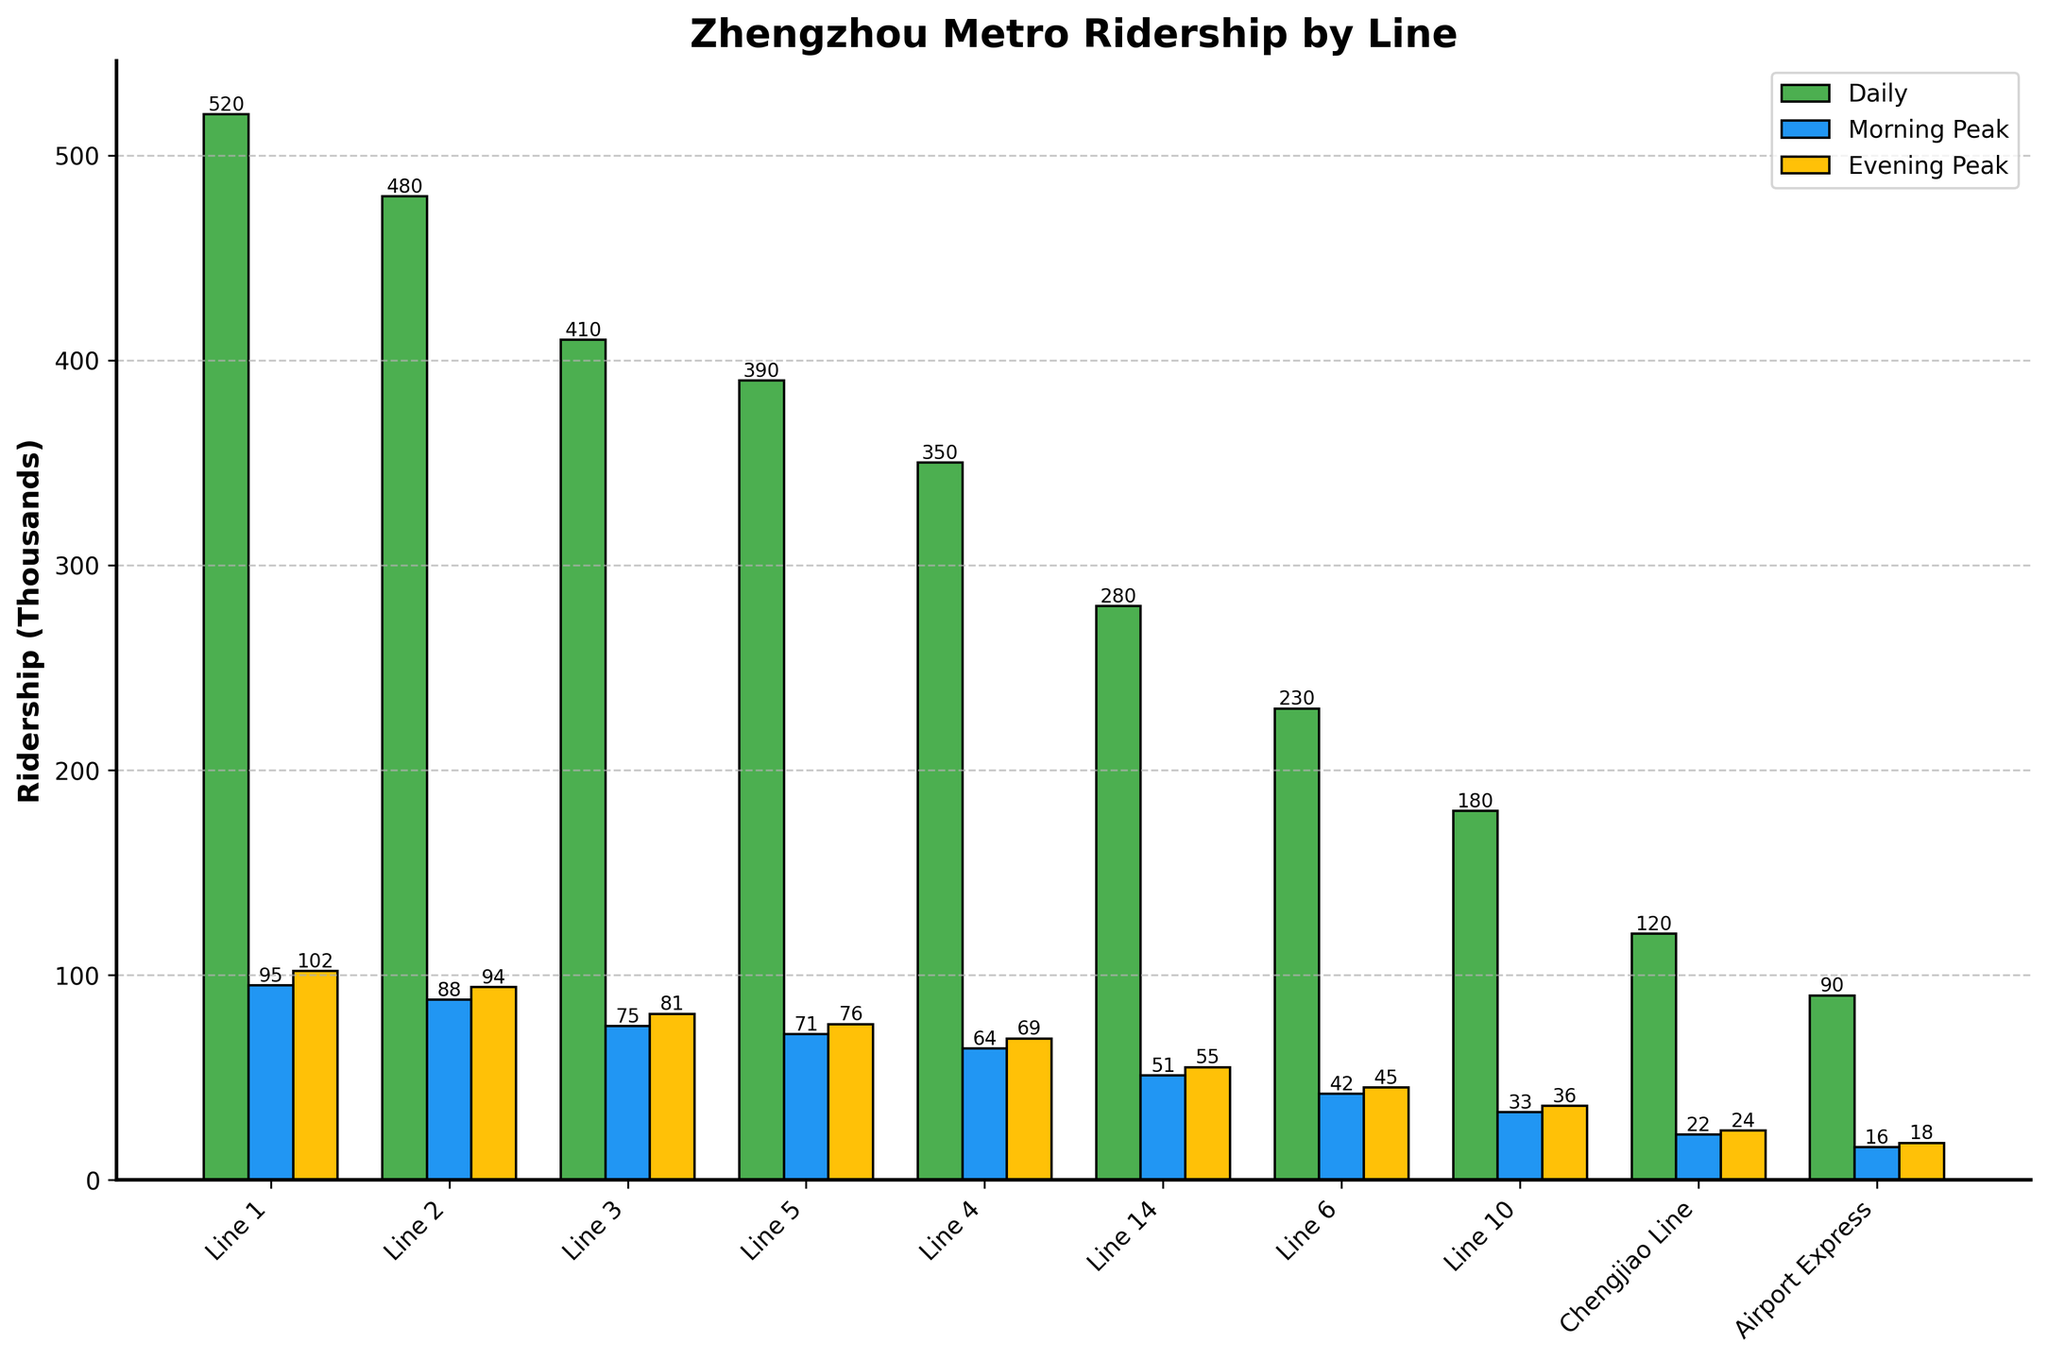Which metro line has the highest daily ridership? To find the line with the highest daily ridership, look at the green bars, which represent daily ridership. Identify the tallest green bar.
Answer: Line 1 What's the combined ridership during peak hours (7-9 AM and 5-7 PM) for Line 2? Sum the ridership for the morning and evening peak hours for Line 2: 88,000 (morning) + 94,000 (evening).
Answer: 182,000 Which metro lines have lower evening peak ridership compared to Line 5's morning peak ridership? Compare the evening peak ridership of all lines (yellow bars) with the morning peak ridership of Line 5 (blue bar) which is 71,000. Lines with lower evening peak ridership than 71,000 are Lines 6, 10, Chengjiao Line, and Airport Express.
Answer: Line 6, Line 10, Chengjiao Line, Airport Express What is the difference in daily ridership between Line 3 and Line 4? Subtract the daily ridership of Line 4 from Line 3: 410,000 - 350,000.
Answer: 60,000 Which metro line has the smallest morning peak hour ridership? Look at the blue bars representing morning peak hour ridership and identify the shortest one.
Answer: Airport Express What percentage of Line 1's daily ridership occurs during the evening peak hour? Divide the evening peak hour ridership of Line 1 by its daily ridership and multiply by 100: (102,000 / 520,000) * 100.
Answer: 19.62% Which metro line has a higher morning peak ridership compared to its evening peak ridership? Compare the blue and yellow bars within each line. Line 1, Line 2, Line 3, Line 4, Line 5, Line 6, Line 10, and Chengjiao Line have lower morning peak ridership compared to evening except for Airport Express, which has 16,000 in the morning and 18,000 in the evening.
Answer: None How many lines have a daily ridership of more than 400,000? Count the green bars where the value is above 400,000. Lines with more than 400,000 daily ridership are Line 1, Line 2, and Line 3.
Answer: 3 What is the average daily ridership of all metro lines? Sum the daily riderships and divide by the number of lines. (520,000 + 480,000 + 410,000 + 390,000 + 350,000 + 280,000 + 230,000 + 180,000 + 120,000 + 90,000) / 10.
Answer: 305,000 